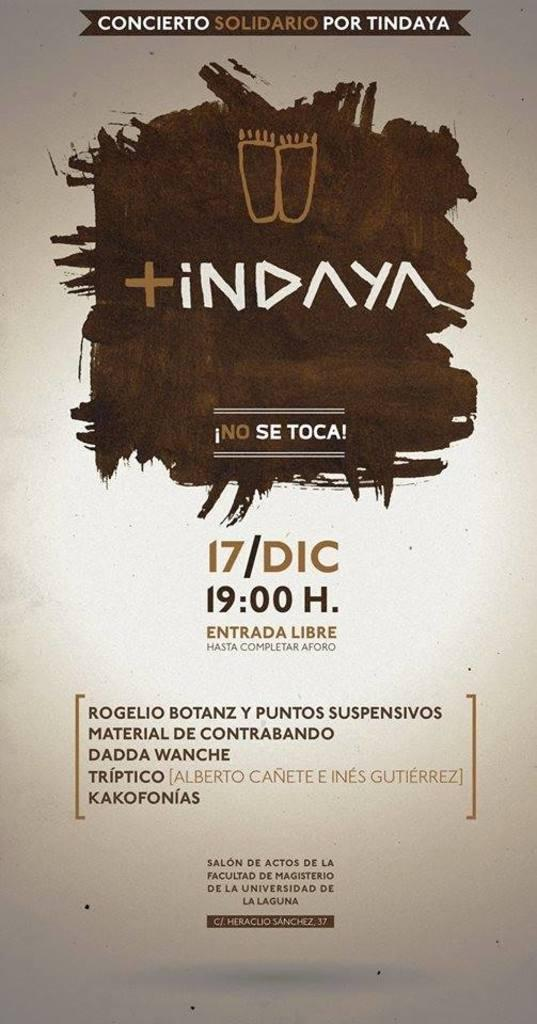<image>
Provide a brief description of the given image. Brown and tan concert poster with a top banner stating concierto solidario por tindaya. 